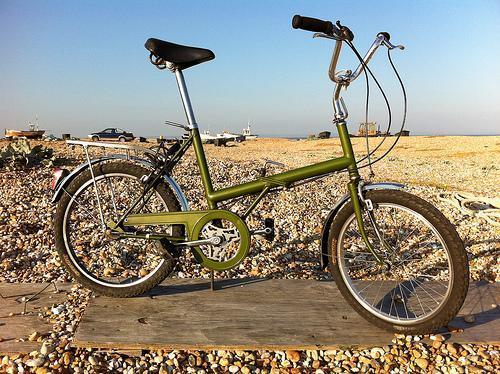How many tires are on the bike?
Give a very brief answer. 2. 